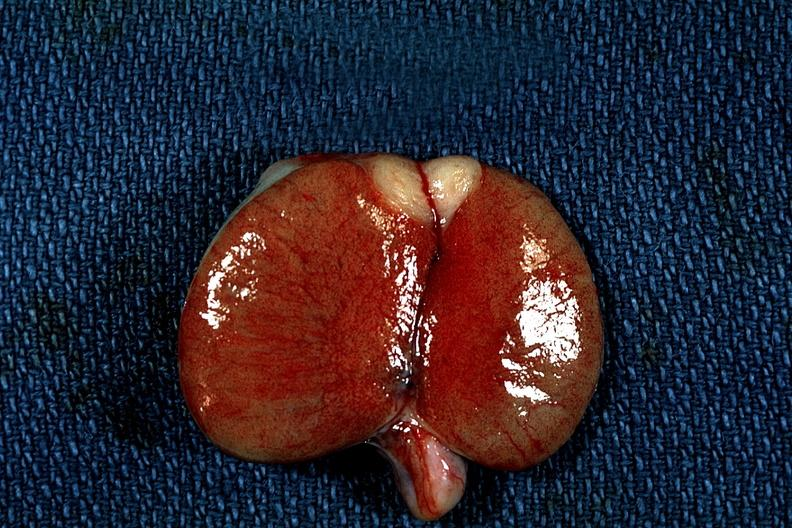s metastatic carcinoma present?
Answer the question using a single word or phrase. Yes 